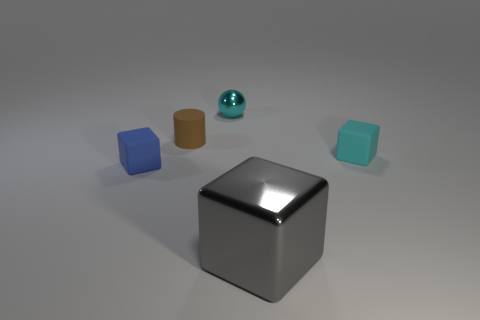Add 2 small matte cylinders. How many objects exist? 7 Subtract all blocks. How many objects are left? 2 Subtract all shiny objects. Subtract all cyan metal objects. How many objects are left? 2 Add 4 gray blocks. How many gray blocks are left? 5 Add 5 brown metallic cylinders. How many brown metallic cylinders exist? 5 Subtract 0 yellow balls. How many objects are left? 5 